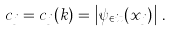Convert formula to latex. <formula><loc_0><loc_0><loc_500><loc_500>c _ { j } = c _ { j } ( k ) = \left | \psi _ { \in i t } ( x _ { j } ) \right | \, .</formula> 